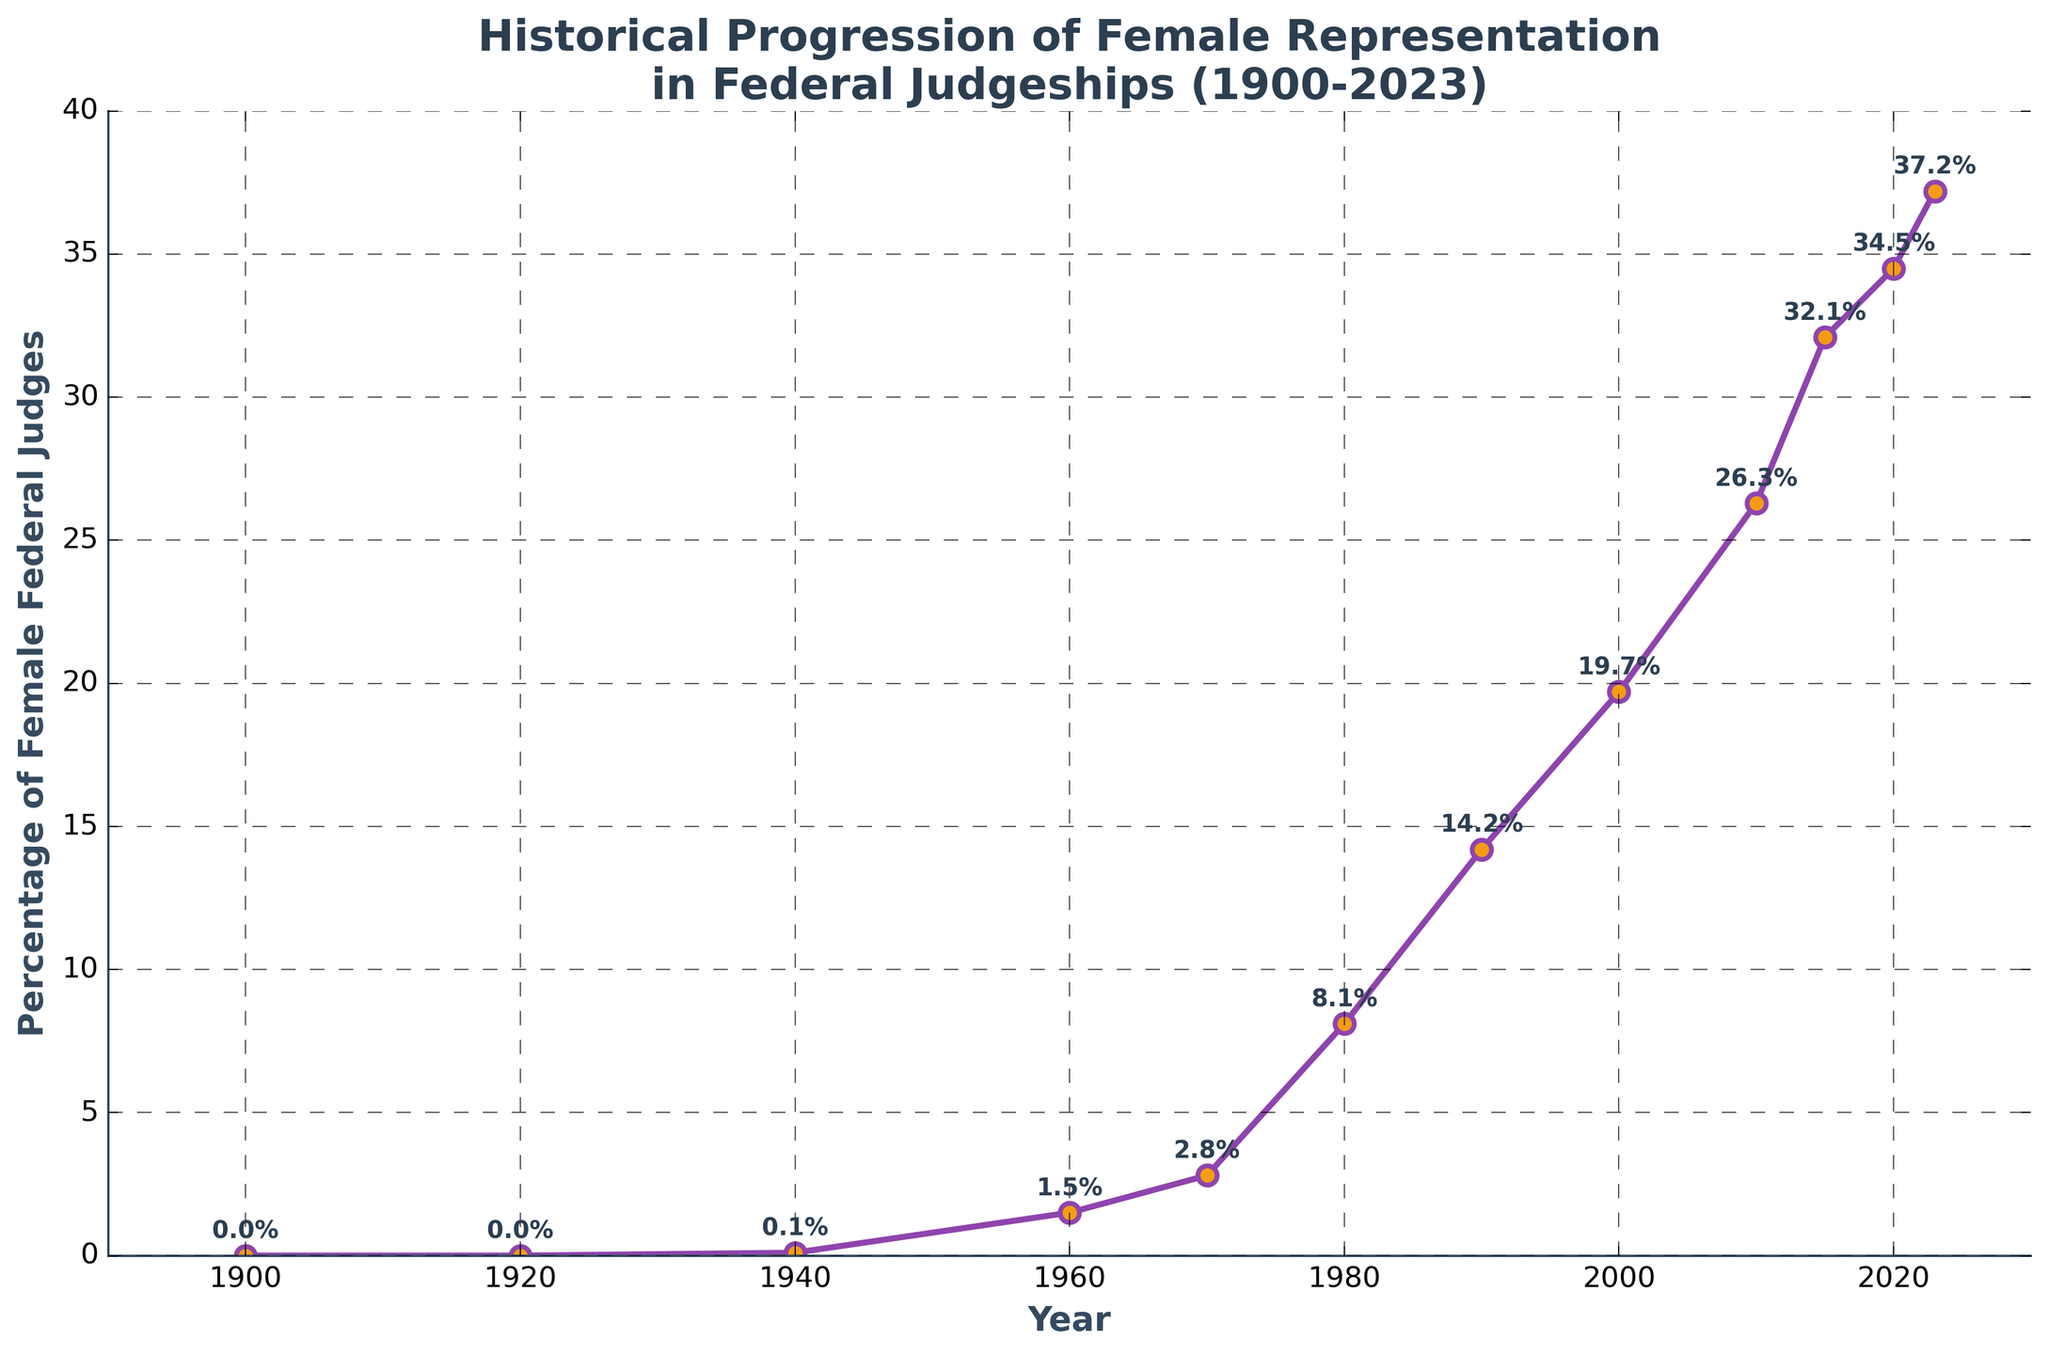What year had the highest percentage of female federal judges? The figure shows a line chart with the percentage of female federal judges increasing over time. The highest data point appears at the far right end of the chart in 2023, with the percentage labeled as 37.2%.
Answer: 2023 How much did the percentage of female federal judges increase between 1980 and 2000? In 1980, the percentage of female federal judges was 8.1%, and in 2000, it was 19.7%. The increase can be calculated by subtracting the 1980 value from the 2000 value: 19.7% - 8.1% = 11.6%.
Answer: 11.6% Between which consecutive decades did the percentage of female federal judges increase the most? By examining the chart, you can see the most significant increase between consecutive decades. The steepest increase occurs between 1970 (2.8%) and 1980 (8.1%). The difference is 8.1% - 2.8% = 5.3%.
Answer: 1970 to 1980 What is the approximate average percentage of female federal judges from 1900 to 2023? To find the average, add all the percentage values and then divide by the number of data points. The values are: 0 + 0 + 0.1 + 1.5 + 2.8 + 8.1 + 14.2 + 19.7 + 26.3 + 32.1 + 34.5 + 37.2. The sum is 176.5. There are 12 data points. So, the average is 176.5 / 12 ≈ 14.71%.
Answer: 14.71% Which year marks the first increase in the percentage of female federal judges? The first increase in the percentage can be observed by identifying the first year with a non-zero percentage after consecutive zeros. The chart shows an increase in 1940, with a percentage of 0.1%.
Answer: 1940 In what year did the percentage of female federal judges first surpass 10%? By looking at the percentages labeled on the chart, the first year the percentage surpasses 10% is 1990, with a percentage of 14.2%.
Answer: 1990 How does the percentage change from 2010 to 2023? The percentage in 2010 is 26.3%, and in 2023 it is 37.2%. The change can be calculated by subtracting the 2010 value from the 2023 value: 37.2% - 26.3% = 10.9%.
Answer: 10.9% What visual feature indicates major increases in the percentage of female federal judges? Major increases are indicated by steeper inclines in the line slope on the chart. Periods with steep increases represent significant gains in the percentage of female federal judges.
Answer: Steeper inclines in the line Between which two years did the percentage of female federal judges cross the 20% mark? By closely examining the chart, the percentage crosses 20% between the years 2000 (19.7%) and 2010 (26.3%).
Answer: Between 2000 and 2010 Is the trend of female representation in federal judgeships generally positive, negative, or neutral from 1900 to 2023? By visually analyzing the line chart, the overall trend is positive, as the line increases steadily from 0% in 1900 to 37.2% in 2023.
Answer: Positive 